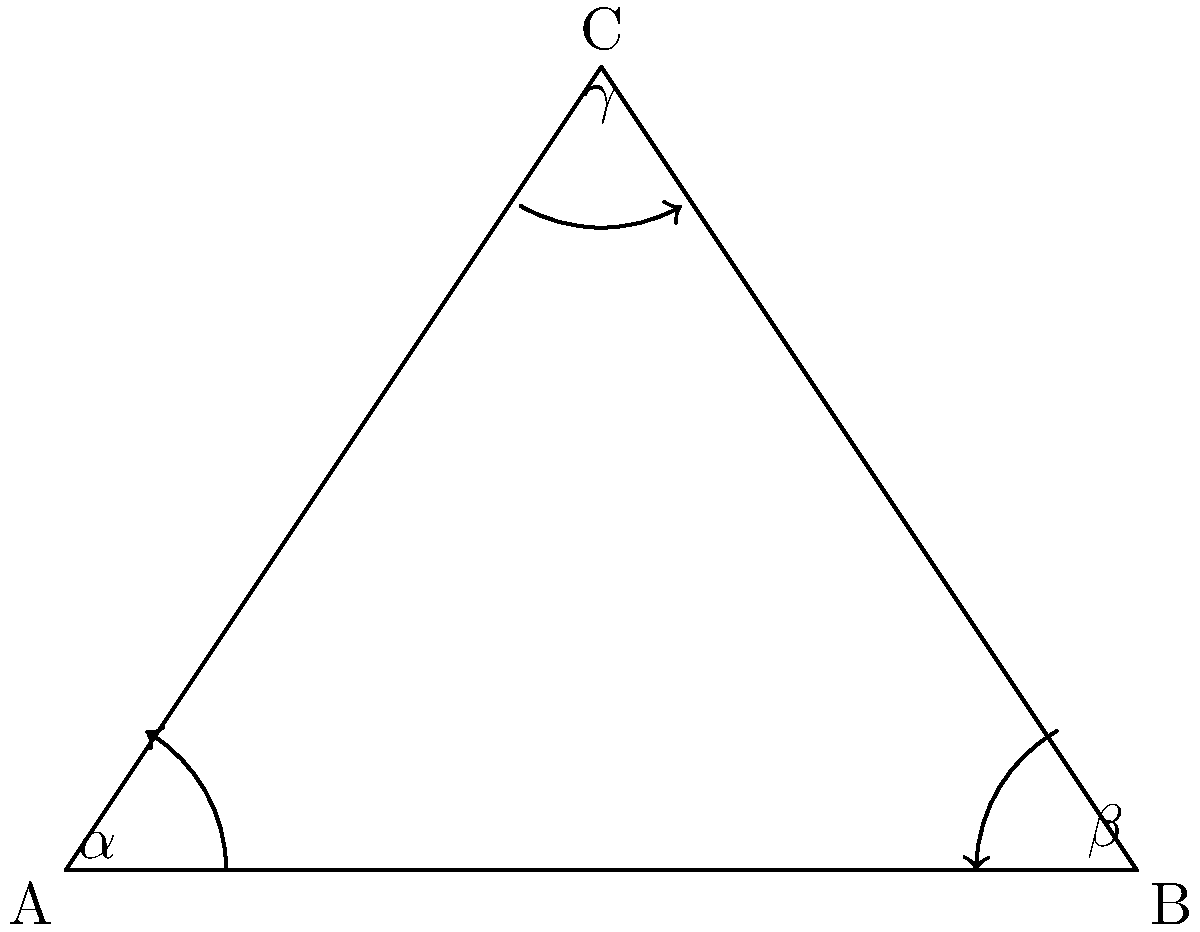In a hyperbolic triangle ABC, the angles are $\alpha$, $\beta$, and $\gamma$. If the sum of these angles is $\frac{5\pi}{6}$, what is the area of the triangle in terms of $\pi$? (Hint: Use the Gauss-Bonnet formula for hyperbolic triangles) To solve this problem, we'll use the Gauss-Bonnet formula for hyperbolic triangles:

1) The Gauss-Bonnet formula states: $\alpha + \beta + \gamma + A = \pi$
   Where $A$ is the area of the hyperbolic triangle.

2) We're given that $\alpha + \beta + \gamma = \frac{5\pi}{6}$

3) Substituting this into the Gauss-Bonnet formula:
   $\frac{5\pi}{6} + A = \pi$

4) Subtracting $\frac{5\pi}{6}$ from both sides:
   $A = \pi - \frac{5\pi}{6}$

5) Simplifying:
   $A = \frac{\pi}{6}$

Therefore, the area of the hyperbolic triangle is $\frac{\pi}{6}$.
Answer: $\frac{\pi}{6}$ 